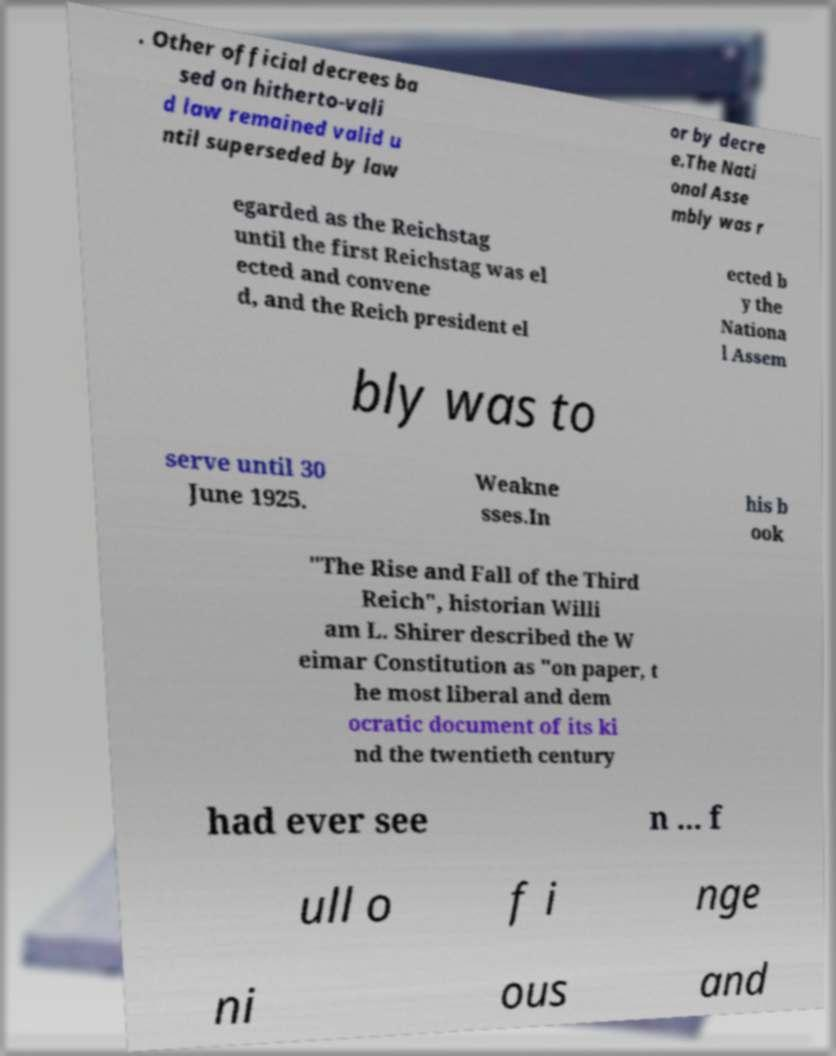What messages or text are displayed in this image? I need them in a readable, typed format. . Other official decrees ba sed on hitherto-vali d law remained valid u ntil superseded by law or by decre e.The Nati onal Asse mbly was r egarded as the Reichstag until the first Reichstag was el ected and convene d, and the Reich president el ected b y the Nationa l Assem bly was to serve until 30 June 1925. Weakne sses.In his b ook "The Rise and Fall of the Third Reich", historian Willi am L. Shirer described the W eimar Constitution as "on paper, t he most liberal and dem ocratic document of its ki nd the twentieth century had ever see n ... f ull o f i nge ni ous and 